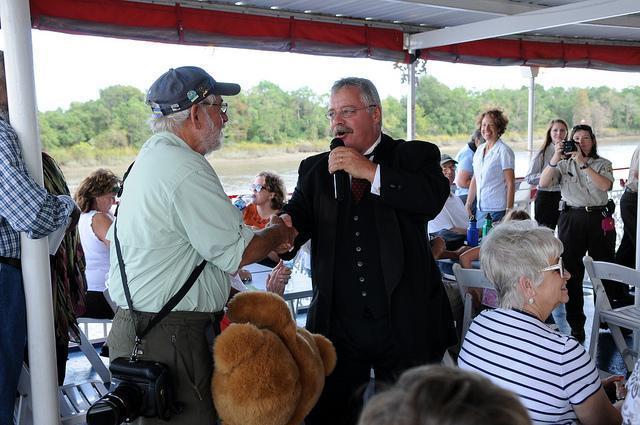How many people are there?
Give a very brief answer. 8. 